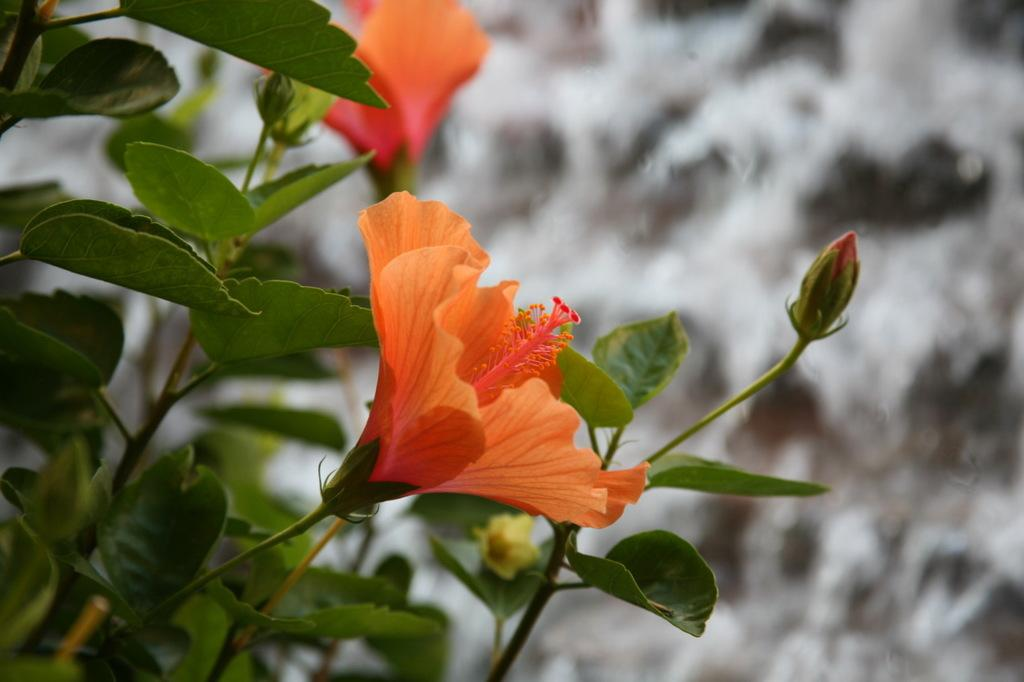What type of flowers are in the image? There are hibiscus flowers in the image. What color are the hibiscus flowers? The hibiscus flowers are orange in color. To which plant do these flowers belong? The flowers belong to a plant. How would you describe the background of the image? The background of the image is blurred. What type of activity is taking place in the image involving a pig? There is no pig or activity involving a pig present in the image. 